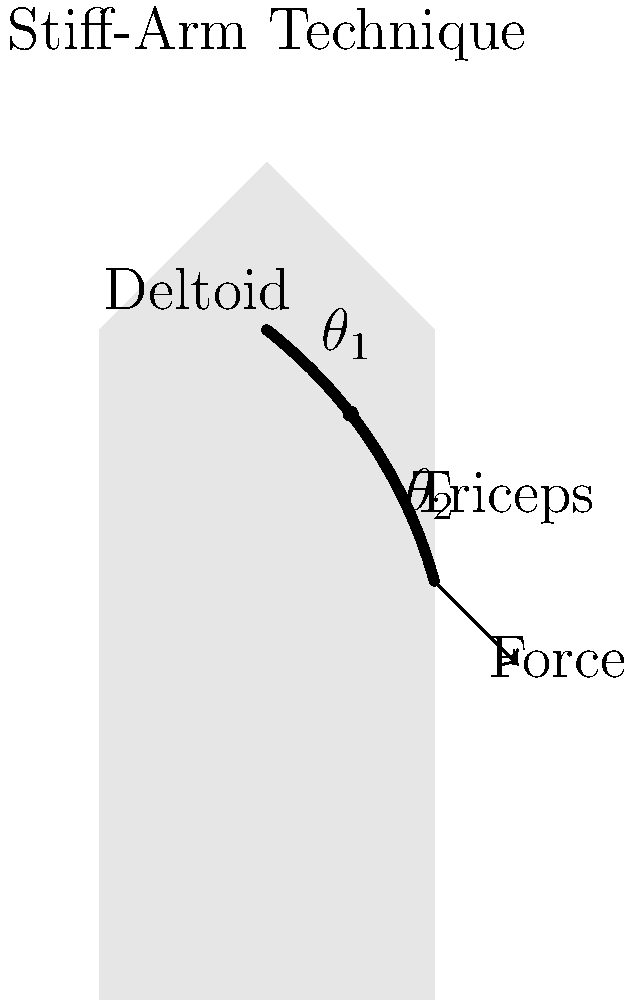Analyze the biomechanics of the stiff-arm technique shown in the diagram. If the running back aims to maximize the force applied during the stiff-arm, what should be the optimal angle $\theta_2$ between the upper arm and forearm, and why? Consider muscle activation patterns and leverage principles in your answer. To determine the optimal angle $\theta_2$ for maximizing force in a stiff-arm technique, we need to consider several biomechanical factors:

1. Muscle Force-Length Relationship:
   - The triceps brachii is the primary muscle involved in elbow extension during a stiff-arm.
   - Muscles generate maximum force at their optimal length, typically when stretched to about 120% of their resting length.

2. Moment Arm:
   - The moment arm is the perpendicular distance from the joint axis to the line of action of the muscle force.
   - The effective force at the hand is influenced by the moment arm of the triceps at the elbow.

3. Joint Angle and Leverage:
   - As $\theta_2$ approaches 180° (full extension), the moment arm of the triceps decreases, reducing mechanical advantage.
   - As $\theta_2$ approaches 90°, the moment arm increases, but the muscle may not be at its optimal length.

4. Speed-Force Trade-off:
   - A more extended arm (larger $\theta_2$) allows for quicker application of force but potentially less force.
   - A more flexed arm (smaller $\theta_2$) can generate more force but may be slower to execute.

5. Stability and Control:
   - A slightly flexed elbow provides better control and ability to adjust to the opponent's movements.

Considering these factors, the optimal angle $\theta_2$ for maximizing force in a stiff-arm technique is approximately 135-150°. This range allows for:

- Near-optimal triceps length for force production
- A favorable moment arm for the triceps
- Good balance between force production and speed of execution
- Sufficient stability and control

This angle also aligns with the principle of optimal pennation angle in muscle architecture, where muscle fibers are oriented at an angle that maximizes force transmission to the tendon.
Answer: 135-150° 